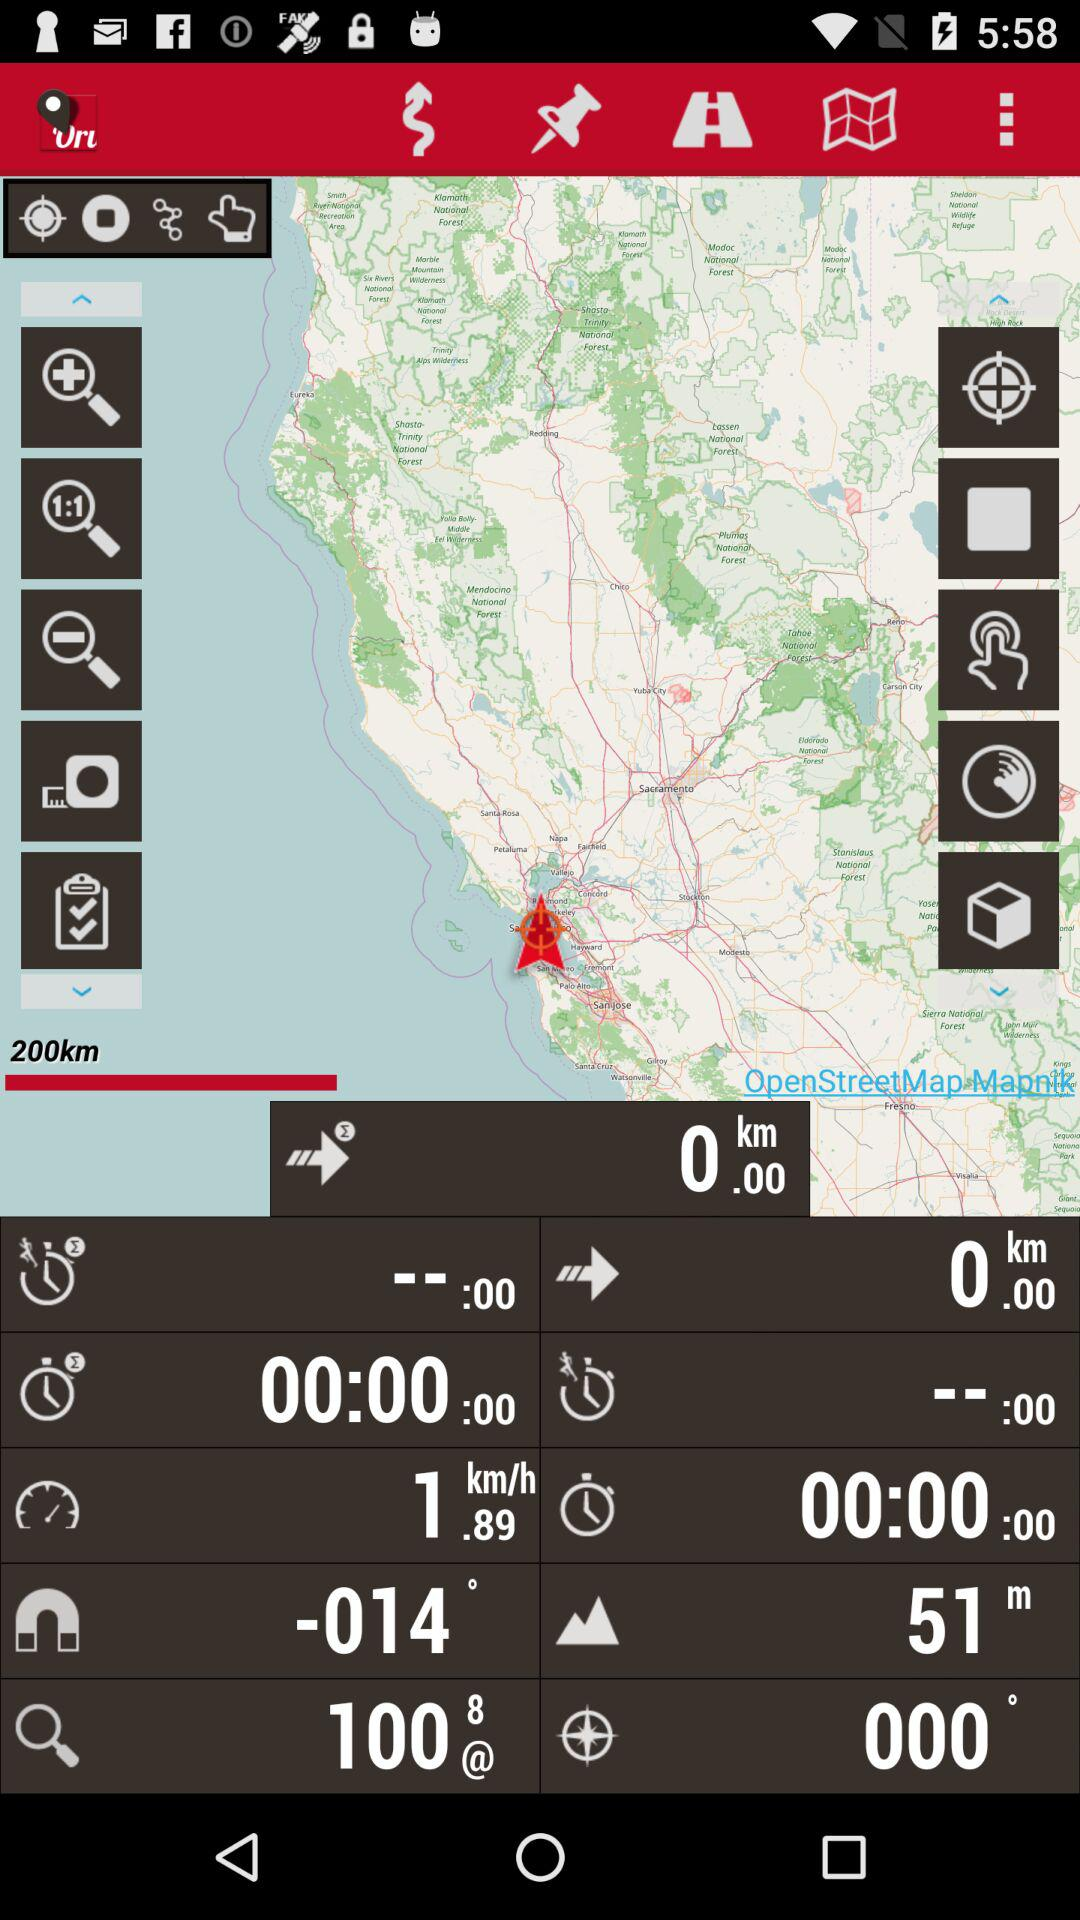What is the speed? The speed is 1.89 km/h. 